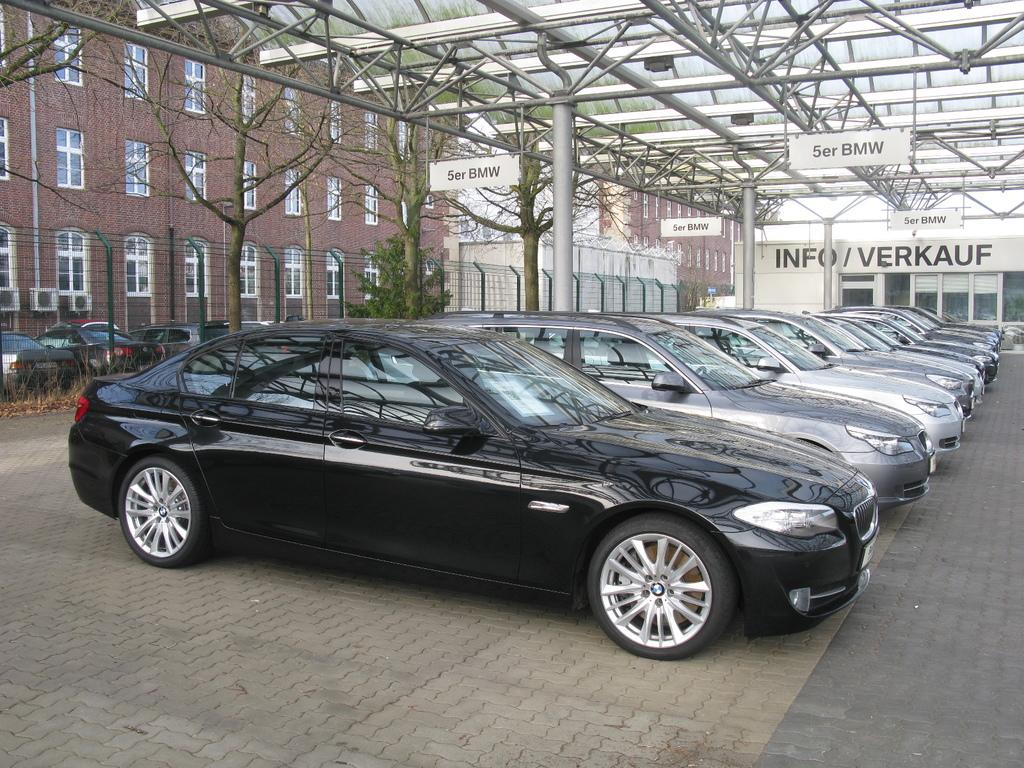What type of vehicles can be seen in the image? There are many cars in the image. What colors are the cars? The cars are black and gray in color. What else can be seen in the background of the image? There are other vehicles, railing, dried trees, and buildings in the background of the image. What colors are the buildings in the background? The buildings are in cream and brown colors. What type of hope can be seen in the image? There is no hope present in the image; it is a photograph of cars, other vehicles, railing, dried trees, and buildings. What type of pleasure can be derived from the image? The image is not meant to provide pleasure; it is a factual description of the objects and colors present in the photograph. 